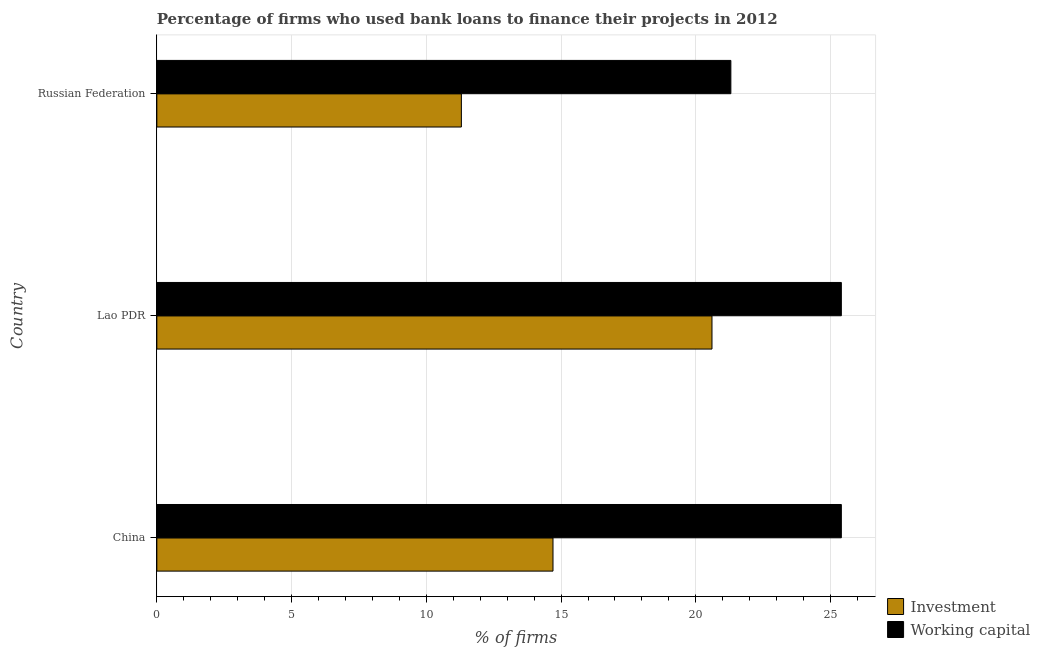How many groups of bars are there?
Your answer should be very brief. 3. Are the number of bars per tick equal to the number of legend labels?
Provide a short and direct response. Yes. Across all countries, what is the maximum percentage of firms using banks to finance investment?
Your answer should be compact. 20.6. In which country was the percentage of firms using banks to finance working capital maximum?
Your answer should be compact. China. In which country was the percentage of firms using banks to finance working capital minimum?
Make the answer very short. Russian Federation. What is the total percentage of firms using banks to finance investment in the graph?
Ensure brevity in your answer.  46.6. What is the difference between the percentage of firms using banks to finance investment in China and that in Russian Federation?
Provide a short and direct response. 3.4. What is the difference between the percentage of firms using banks to finance investment in China and the percentage of firms using banks to finance working capital in Russian Federation?
Offer a terse response. -6.6. What is the average percentage of firms using banks to finance working capital per country?
Provide a succinct answer. 24.03. What is the difference between the percentage of firms using banks to finance investment and percentage of firms using banks to finance working capital in China?
Your response must be concise. -10.7. What is the difference between the highest and the second highest percentage of firms using banks to finance investment?
Provide a succinct answer. 5.9. In how many countries, is the percentage of firms using banks to finance investment greater than the average percentage of firms using banks to finance investment taken over all countries?
Provide a succinct answer. 1. Is the sum of the percentage of firms using banks to finance investment in Lao PDR and Russian Federation greater than the maximum percentage of firms using banks to finance working capital across all countries?
Ensure brevity in your answer.  Yes. What does the 2nd bar from the top in Russian Federation represents?
Offer a terse response. Investment. What does the 1st bar from the bottom in Russian Federation represents?
Provide a succinct answer. Investment. Are the values on the major ticks of X-axis written in scientific E-notation?
Your answer should be compact. No. Does the graph contain grids?
Provide a short and direct response. Yes. Where does the legend appear in the graph?
Give a very brief answer. Bottom right. How many legend labels are there?
Provide a succinct answer. 2. What is the title of the graph?
Make the answer very short. Percentage of firms who used bank loans to finance their projects in 2012. What is the label or title of the X-axis?
Your answer should be compact. % of firms. What is the label or title of the Y-axis?
Ensure brevity in your answer.  Country. What is the % of firms in Working capital in China?
Keep it short and to the point. 25.4. What is the % of firms in Investment in Lao PDR?
Offer a very short reply. 20.6. What is the % of firms of Working capital in Lao PDR?
Give a very brief answer. 25.4. What is the % of firms of Working capital in Russian Federation?
Your answer should be compact. 21.3. Across all countries, what is the maximum % of firms of Investment?
Give a very brief answer. 20.6. Across all countries, what is the maximum % of firms in Working capital?
Your answer should be very brief. 25.4. Across all countries, what is the minimum % of firms of Investment?
Your answer should be very brief. 11.3. Across all countries, what is the minimum % of firms of Working capital?
Keep it short and to the point. 21.3. What is the total % of firms in Investment in the graph?
Keep it short and to the point. 46.6. What is the total % of firms of Working capital in the graph?
Offer a terse response. 72.1. What is the difference between the % of firms in Working capital in China and that in Russian Federation?
Ensure brevity in your answer.  4.1. What is the difference between the % of firms of Investment in Lao PDR and that in Russian Federation?
Your answer should be compact. 9.3. What is the difference between the % of firms of Working capital in Lao PDR and that in Russian Federation?
Keep it short and to the point. 4.1. What is the difference between the % of firms of Investment in China and the % of firms of Working capital in Russian Federation?
Keep it short and to the point. -6.6. What is the difference between the % of firms of Investment in Lao PDR and the % of firms of Working capital in Russian Federation?
Provide a short and direct response. -0.7. What is the average % of firms in Investment per country?
Your answer should be very brief. 15.53. What is the average % of firms in Working capital per country?
Your answer should be very brief. 24.03. What is the difference between the % of firms of Investment and % of firms of Working capital in Russian Federation?
Keep it short and to the point. -10. What is the ratio of the % of firms in Investment in China to that in Lao PDR?
Offer a terse response. 0.71. What is the ratio of the % of firms of Working capital in China to that in Lao PDR?
Give a very brief answer. 1. What is the ratio of the % of firms of Investment in China to that in Russian Federation?
Your answer should be compact. 1.3. What is the ratio of the % of firms in Working capital in China to that in Russian Federation?
Your answer should be very brief. 1.19. What is the ratio of the % of firms in Investment in Lao PDR to that in Russian Federation?
Keep it short and to the point. 1.82. What is the ratio of the % of firms of Working capital in Lao PDR to that in Russian Federation?
Provide a succinct answer. 1.19. What is the difference between the highest and the second highest % of firms of Investment?
Provide a short and direct response. 5.9. What is the difference between the highest and the lowest % of firms in Investment?
Ensure brevity in your answer.  9.3. 